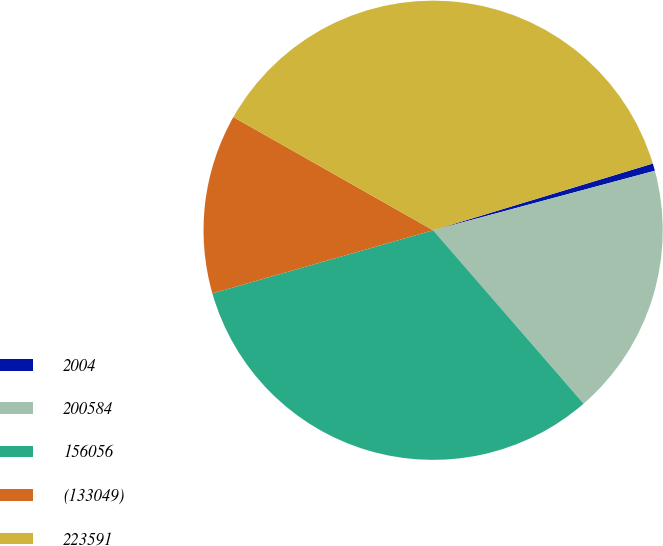<chart> <loc_0><loc_0><loc_500><loc_500><pie_chart><fcel>2004<fcel>200584<fcel>156056<fcel>(133049)<fcel>223591<nl><fcel>0.52%<fcel>17.8%<fcel>31.94%<fcel>12.64%<fcel>37.1%<nl></chart> 